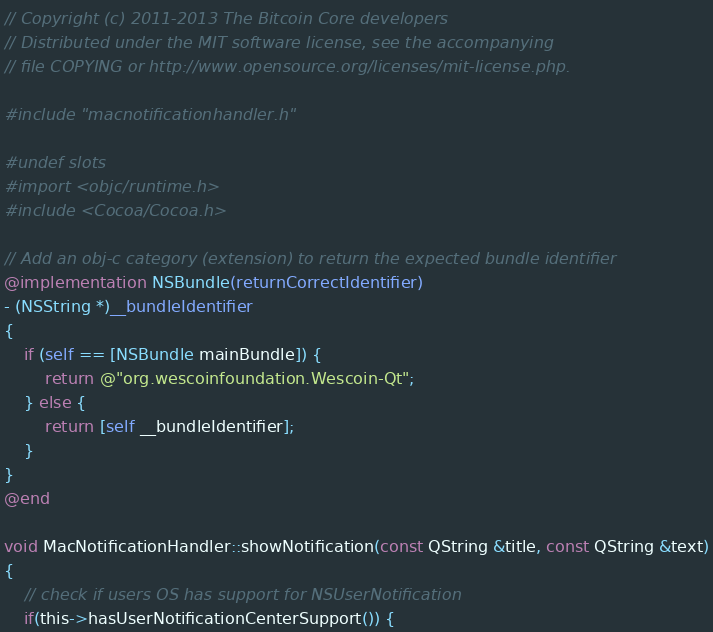Convert code to text. <code><loc_0><loc_0><loc_500><loc_500><_ObjectiveC_>// Copyright (c) 2011-2013 The Bitcoin Core developers
// Distributed under the MIT software license, see the accompanying
// file COPYING or http://www.opensource.org/licenses/mit-license.php.

#include "macnotificationhandler.h"

#undef slots
#import <objc/runtime.h>
#include <Cocoa/Cocoa.h>

// Add an obj-c category (extension) to return the expected bundle identifier
@implementation NSBundle(returnCorrectIdentifier)
- (NSString *)__bundleIdentifier
{
    if (self == [NSBundle mainBundle]) {
        return @"org.wescoinfoundation.Wescoin-Qt";
    } else {
        return [self __bundleIdentifier];
    }
}
@end

void MacNotificationHandler::showNotification(const QString &title, const QString &text)
{
    // check if users OS has support for NSUserNotification
    if(this->hasUserNotificationCenterSupport()) {</code> 